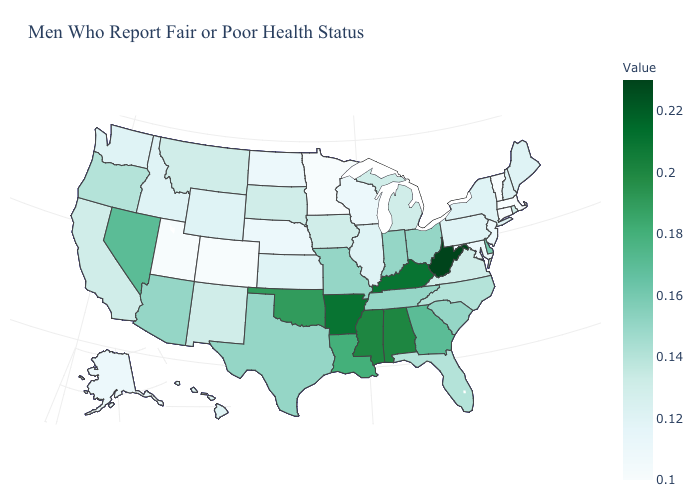Does the map have missing data?
Give a very brief answer. No. Which states hav the highest value in the West?
Keep it brief. Nevada. 